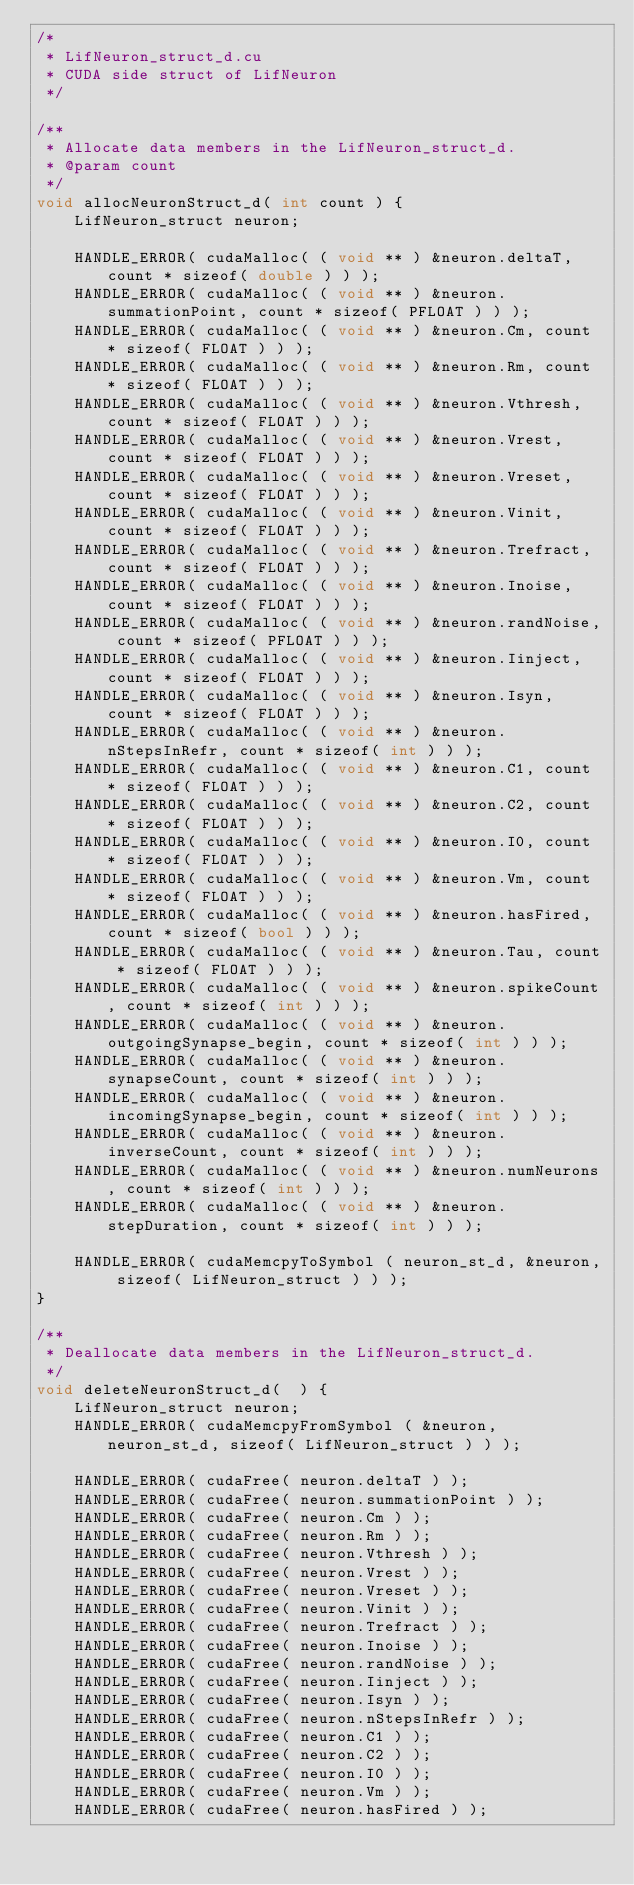Convert code to text. <code><loc_0><loc_0><loc_500><loc_500><_Cuda_>/*
 * LifNeuron_struct_d.cu
 * CUDA side struct of LifNeuron
 */

/**
 * Allocate data members in the LifNeuron_struct_d.
 * @param count
 */
void allocNeuronStruct_d( int count ) {
	LifNeuron_struct neuron;

	HANDLE_ERROR( cudaMalloc( ( void ** ) &neuron.deltaT, count * sizeof( double ) ) );
	HANDLE_ERROR( cudaMalloc( ( void ** ) &neuron.summationPoint, count * sizeof( PFLOAT ) ) );
	HANDLE_ERROR( cudaMalloc( ( void ** ) &neuron.Cm, count * sizeof( FLOAT ) ) );
	HANDLE_ERROR( cudaMalloc( ( void ** ) &neuron.Rm, count * sizeof( FLOAT ) ) );
	HANDLE_ERROR( cudaMalloc( ( void ** ) &neuron.Vthresh, count * sizeof( FLOAT ) ) );
	HANDLE_ERROR( cudaMalloc( ( void ** ) &neuron.Vrest, count * sizeof( FLOAT ) ) );
	HANDLE_ERROR( cudaMalloc( ( void ** ) &neuron.Vreset, count * sizeof( FLOAT ) ) );
	HANDLE_ERROR( cudaMalloc( ( void ** ) &neuron.Vinit, count * sizeof( FLOAT ) ) );
	HANDLE_ERROR( cudaMalloc( ( void ** ) &neuron.Trefract, count * sizeof( FLOAT ) ) );
	HANDLE_ERROR( cudaMalloc( ( void ** ) &neuron.Inoise, count * sizeof( FLOAT ) ) );
	HANDLE_ERROR( cudaMalloc( ( void ** ) &neuron.randNoise, count * sizeof( PFLOAT ) ) );
	HANDLE_ERROR( cudaMalloc( ( void ** ) &neuron.Iinject, count * sizeof( FLOAT ) ) );
	HANDLE_ERROR( cudaMalloc( ( void ** ) &neuron.Isyn, count * sizeof( FLOAT ) ) );
	HANDLE_ERROR( cudaMalloc( ( void ** ) &neuron.nStepsInRefr, count * sizeof( int ) ) );
	HANDLE_ERROR( cudaMalloc( ( void ** ) &neuron.C1, count * sizeof( FLOAT ) ) );
	HANDLE_ERROR( cudaMalloc( ( void ** ) &neuron.C2, count * sizeof( FLOAT ) ) );
	HANDLE_ERROR( cudaMalloc( ( void ** ) &neuron.I0, count * sizeof( FLOAT ) ) );
	HANDLE_ERROR( cudaMalloc( ( void ** ) &neuron.Vm, count * sizeof( FLOAT ) ) );
	HANDLE_ERROR( cudaMalloc( ( void ** ) &neuron.hasFired, count * sizeof( bool ) ) );
	HANDLE_ERROR( cudaMalloc( ( void ** ) &neuron.Tau, count * sizeof( FLOAT ) ) );
	HANDLE_ERROR( cudaMalloc( ( void ** ) &neuron.spikeCount, count * sizeof( int ) ) );
	HANDLE_ERROR( cudaMalloc( ( void ** ) &neuron.outgoingSynapse_begin, count * sizeof( int ) ) );
	HANDLE_ERROR( cudaMalloc( ( void ** ) &neuron.synapseCount, count * sizeof( int ) ) );
	HANDLE_ERROR( cudaMalloc( ( void ** ) &neuron.incomingSynapse_begin, count * sizeof( int ) ) );
	HANDLE_ERROR( cudaMalloc( ( void ** ) &neuron.inverseCount, count * sizeof( int ) ) );
	HANDLE_ERROR( cudaMalloc( ( void ** ) &neuron.numNeurons, count * sizeof( int ) ) );
	HANDLE_ERROR( cudaMalloc( ( void ** ) &neuron.stepDuration, count * sizeof( int ) ) );
	
	HANDLE_ERROR( cudaMemcpyToSymbol ( neuron_st_d, &neuron, sizeof( LifNeuron_struct ) ) );
}

/**
 * Deallocate data members in the LifNeuron_struct_d.
 */
void deleteNeuronStruct_d(  ) {
	LifNeuron_struct neuron;
	HANDLE_ERROR( cudaMemcpyFromSymbol ( &neuron, neuron_st_d, sizeof( LifNeuron_struct ) ) );

	HANDLE_ERROR( cudaFree( neuron.deltaT ) );
	HANDLE_ERROR( cudaFree( neuron.summationPoint ) );
	HANDLE_ERROR( cudaFree( neuron.Cm ) );
	HANDLE_ERROR( cudaFree( neuron.Rm ) );
	HANDLE_ERROR( cudaFree( neuron.Vthresh ) );
	HANDLE_ERROR( cudaFree( neuron.Vrest ) );
	HANDLE_ERROR( cudaFree( neuron.Vreset ) );
	HANDLE_ERROR( cudaFree( neuron.Vinit ) );
	HANDLE_ERROR( cudaFree( neuron.Trefract ) );
	HANDLE_ERROR( cudaFree( neuron.Inoise ) );
	HANDLE_ERROR( cudaFree( neuron.randNoise ) );
	HANDLE_ERROR( cudaFree( neuron.Iinject ) );
	HANDLE_ERROR( cudaFree( neuron.Isyn ) );
	HANDLE_ERROR( cudaFree( neuron.nStepsInRefr ) );
	HANDLE_ERROR( cudaFree( neuron.C1 ) );
	HANDLE_ERROR( cudaFree( neuron.C2 ) );
	HANDLE_ERROR( cudaFree( neuron.I0 ) );
	HANDLE_ERROR( cudaFree( neuron.Vm ) );
	HANDLE_ERROR( cudaFree( neuron.hasFired ) );</code> 